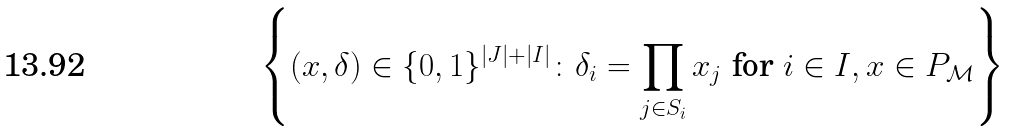Convert formula to latex. <formula><loc_0><loc_0><loc_500><loc_500>\left \{ ( x , \delta ) \in \{ 0 , 1 \} ^ { | J | + | I | } \colon \delta _ { i } = \prod _ { j \in S _ { i } } x _ { j } \text { for } i \in I , x \in P _ { \mathcal { M } } \right \}</formula> 